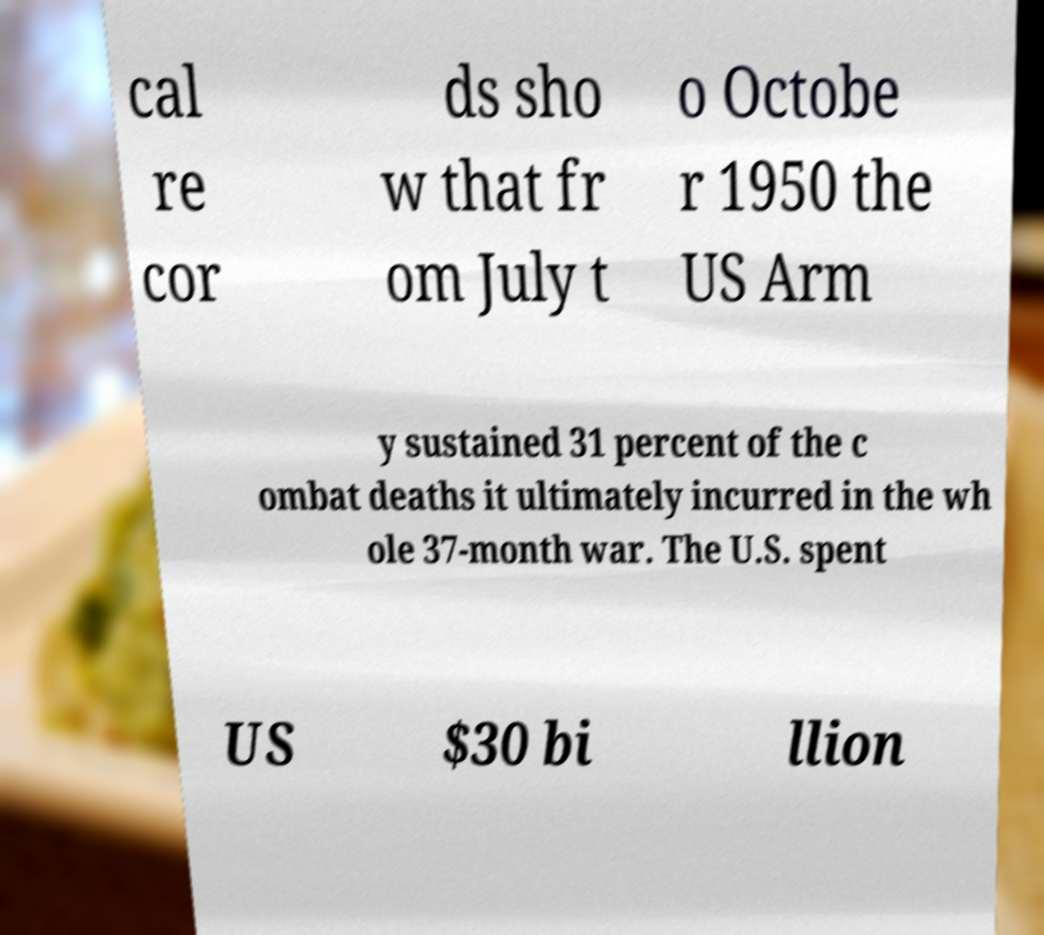There's text embedded in this image that I need extracted. Can you transcribe it verbatim? cal re cor ds sho w that fr om July t o Octobe r 1950 the US Arm y sustained 31 percent of the c ombat deaths it ultimately incurred in the wh ole 37-month war. The U.S. spent US $30 bi llion 